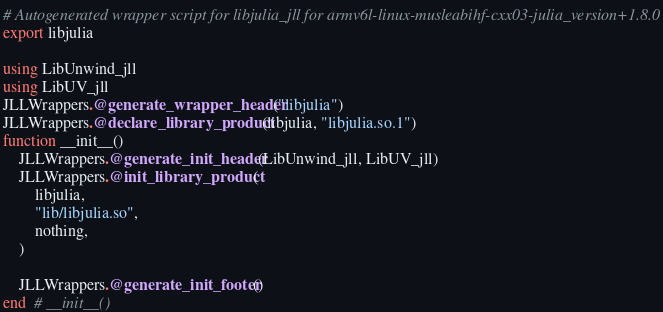<code> <loc_0><loc_0><loc_500><loc_500><_Julia_># Autogenerated wrapper script for libjulia_jll for armv6l-linux-musleabihf-cxx03-julia_version+1.8.0
export libjulia

using LibUnwind_jll
using LibUV_jll
JLLWrappers.@generate_wrapper_header("libjulia")
JLLWrappers.@declare_library_product(libjulia, "libjulia.so.1")
function __init__()
    JLLWrappers.@generate_init_header(LibUnwind_jll, LibUV_jll)
    JLLWrappers.@init_library_product(
        libjulia,
        "lib/libjulia.so",
        nothing,
    )

    JLLWrappers.@generate_init_footer()
end  # __init__()
</code> 